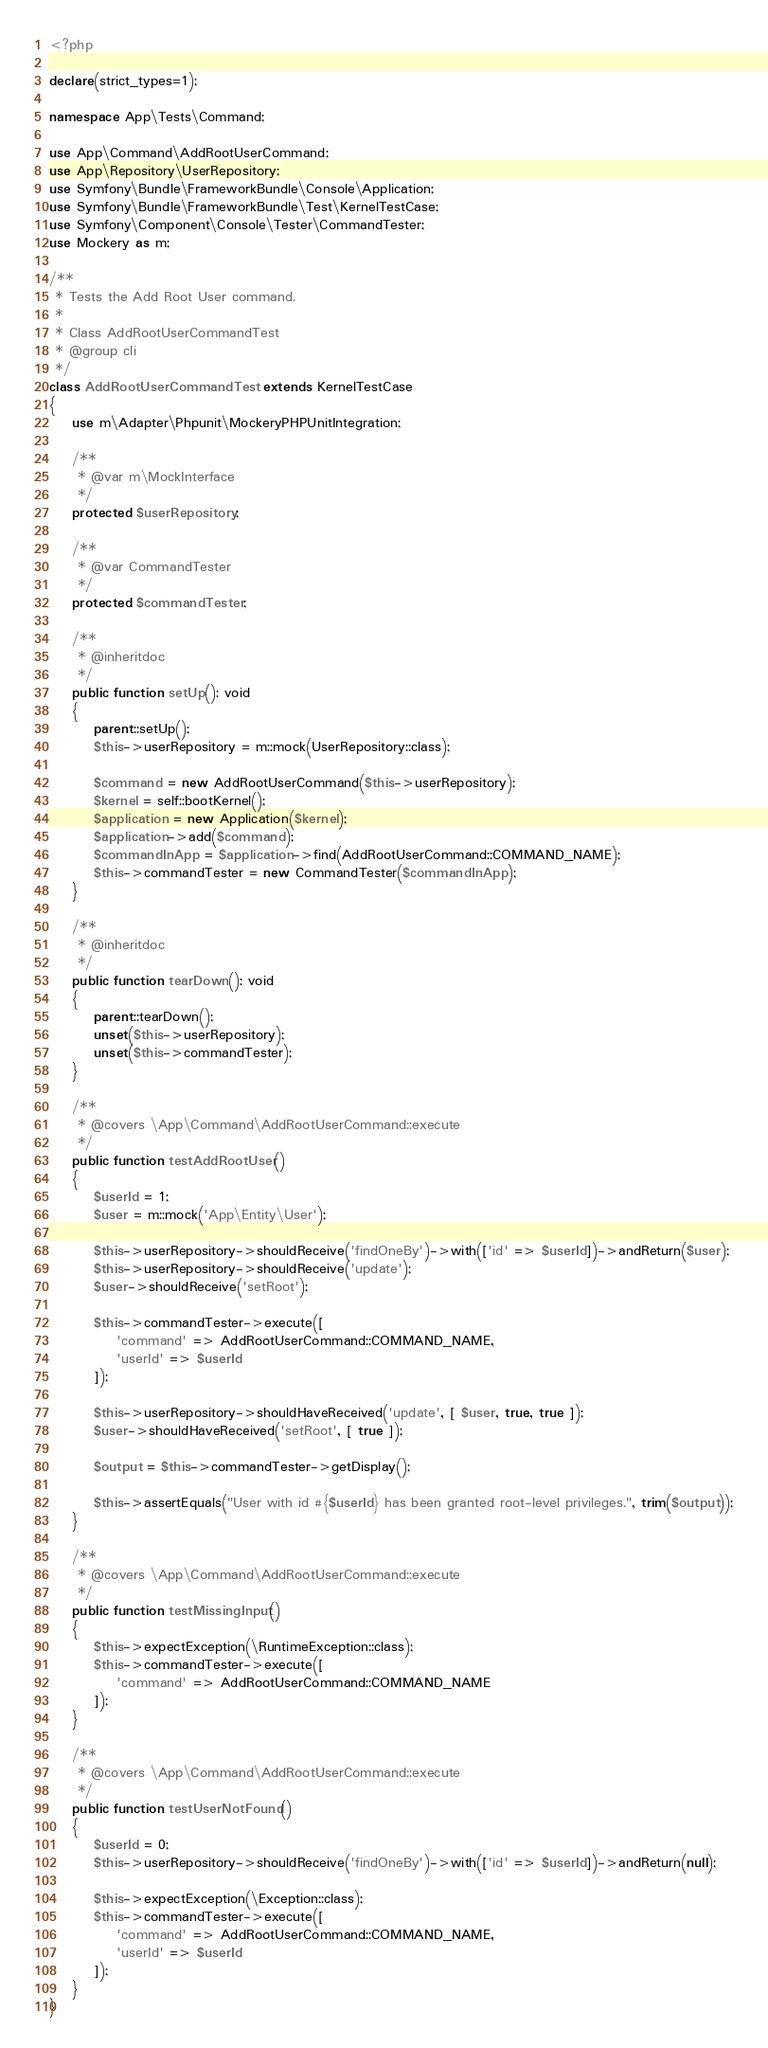Convert code to text. <code><loc_0><loc_0><loc_500><loc_500><_PHP_><?php

declare(strict_types=1);

namespace App\Tests\Command;

use App\Command\AddRootUserCommand;
use App\Repository\UserRepository;
use Symfony\Bundle\FrameworkBundle\Console\Application;
use Symfony\Bundle\FrameworkBundle\Test\KernelTestCase;
use Symfony\Component\Console\Tester\CommandTester;
use Mockery as m;

/**
 * Tests the Add Root User command.
 *
 * Class AddRootUserCommandTest
 * @group cli
 */
class AddRootUserCommandTest extends KernelTestCase
{
    use m\Adapter\Phpunit\MockeryPHPUnitIntegration;

    /**
     * @var m\MockInterface
     */
    protected $userRepository;

    /**
     * @var CommandTester
     */
    protected $commandTester;

    /**
     * @inheritdoc
     */
    public function setUp(): void
    {
        parent::setUp();
        $this->userRepository = m::mock(UserRepository::class);

        $command = new AddRootUserCommand($this->userRepository);
        $kernel = self::bootKernel();
        $application = new Application($kernel);
        $application->add($command);
        $commandInApp = $application->find(AddRootUserCommand::COMMAND_NAME);
        $this->commandTester = new CommandTester($commandInApp);
    }

    /**
     * @inheritdoc
     */
    public function tearDown(): void
    {
        parent::tearDown();
        unset($this->userRepository);
        unset($this->commandTester);
    }

    /**
     * @covers \App\Command\AddRootUserCommand::execute
     */
    public function testAddRootUser()
    {
        $userId = 1;
        $user = m::mock('App\Entity\User');

        $this->userRepository->shouldReceive('findOneBy')->with(['id' => $userId])->andReturn($user);
        $this->userRepository->shouldReceive('update');
        $user->shouldReceive('setRoot');

        $this->commandTester->execute([
            'command' => AddRootUserCommand::COMMAND_NAME,
            'userId' => $userId
        ]);

        $this->userRepository->shouldHaveReceived('update', [ $user, true, true ]);
        $user->shouldHaveReceived('setRoot', [ true ]);

        $output = $this->commandTester->getDisplay();

        $this->assertEquals("User with id #{$userId} has been granted root-level privileges.", trim($output));
    }

    /**
     * @covers \App\Command\AddRootUserCommand::execute
     */
    public function testMissingInput()
    {
        $this->expectException(\RuntimeException::class);
        $this->commandTester->execute([
            'command' => AddRootUserCommand::COMMAND_NAME
        ]);
    }

    /**
     * @covers \App\Command\AddRootUserCommand::execute
     */
    public function testUserNotFound()
    {
        $userId = 0;
        $this->userRepository->shouldReceive('findOneBy')->with(['id' => $userId])->andReturn(null);

        $this->expectException(\Exception::class);
        $this->commandTester->execute([
            'command' => AddRootUserCommand::COMMAND_NAME,
            'userId' => $userId
        ]);
    }
}
</code> 